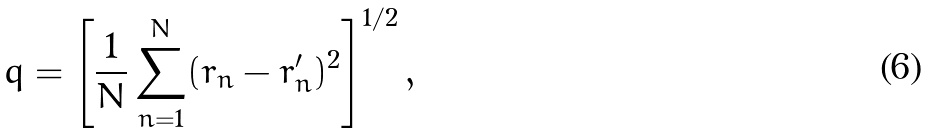Convert formula to latex. <formula><loc_0><loc_0><loc_500><loc_500>q = \left [ \frac { 1 } { N } \sum _ { n = 1 } ^ { N } ( r _ { n } - r _ { n } ^ { \prime } ) ^ { 2 } \right ] ^ { 1 / 2 } ,</formula> 